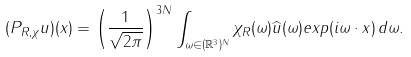<formula> <loc_0><loc_0><loc_500><loc_500>( P _ { R , \chi } u ) ( x ) = \left ( \frac { 1 } { \sqrt { 2 \pi } } \right ) ^ { 3 N } \int _ { \omega \in ( \mathbb { R } ^ { 3 } ) ^ { N } } \chi _ { R } ( \omega ) \widehat { u } ( \omega ) e x p ( i \omega \cdot x ) \, d \omega .</formula> 